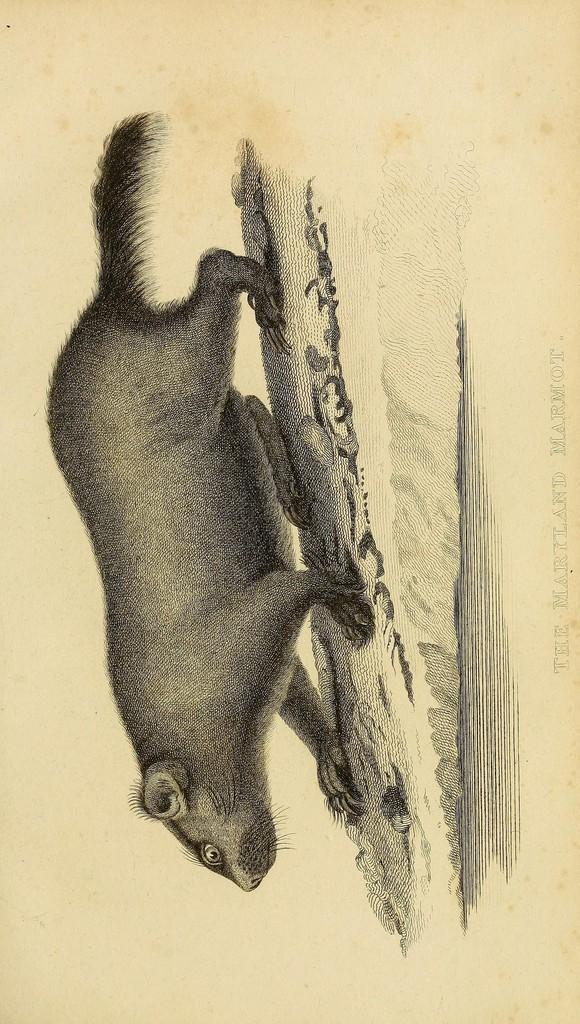Please provide a concise description of this image. In this image I can see an art of an animal on the paper. I can see an art is in black color and the paper is in cream color. 